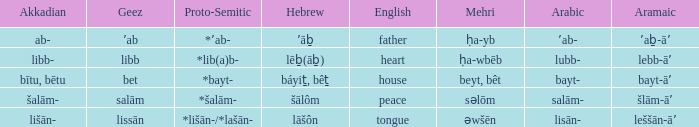Would you mind parsing the complete table? {'header': ['Akkadian', 'Geez', 'Proto-Semitic', 'Hebrew', 'English', 'Mehri', 'Arabic', 'Aramaic'], 'rows': [['ab-', 'ʼab', '*ʼab-', 'ʼāḇ', 'father', 'ḥa-yb', 'ʼab-', 'ʼaḇ-āʼ'], ['libb-', 'libb', '*lib(a)b-', 'lēḇ(āḇ)', 'heart', 'ḥa-wbēb', 'lubb-', 'lebb-āʼ'], ['bītu, bētu', 'bet', '*bayt-', 'báyiṯ, bêṯ', 'house', 'beyt, bêt', 'bayt-', 'bayt-āʼ'], ['šalām-', 'salām', '*šalām-', 'šālôm', 'peace', 'səlōm', 'salām-', 'šlām-āʼ'], ['lišān-', 'lissān', '*lišān-/*lašān-', 'lāšôn', 'tongue', 'əwšēn', 'lisān-', 'leššān-āʼ']]} If the geez is libb, what is the akkadian? Libb-. 